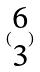Convert formula to latex. <formula><loc_0><loc_0><loc_500><loc_500>( \begin{matrix} 6 \\ 3 \end{matrix} )</formula> 